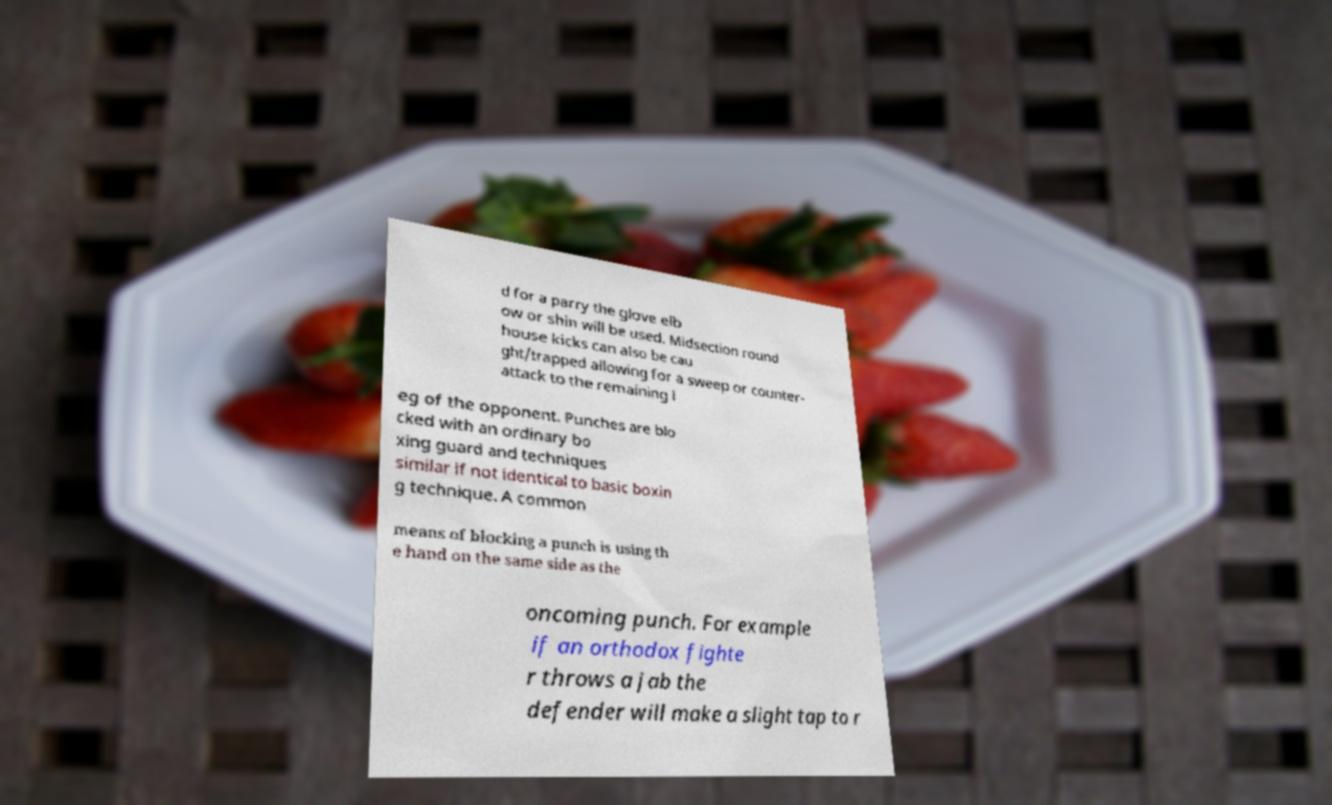Can you accurately transcribe the text from the provided image for me? d for a parry the glove elb ow or shin will be used. Midsection round house kicks can also be cau ght/trapped allowing for a sweep or counter- attack to the remaining l eg of the opponent. Punches are blo cked with an ordinary bo xing guard and techniques similar if not identical to basic boxin g technique. A common means of blocking a punch is using th e hand on the same side as the oncoming punch. For example if an orthodox fighte r throws a jab the defender will make a slight tap to r 